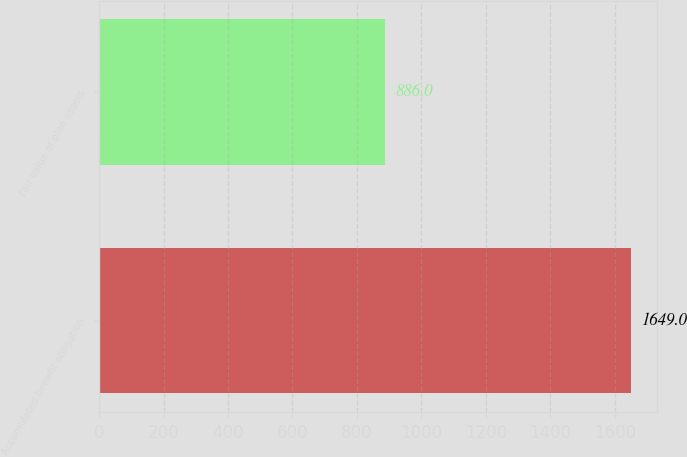Convert chart to OTSL. <chart><loc_0><loc_0><loc_500><loc_500><bar_chart><fcel>Accumulated benefit obligation<fcel>Fair value of plan assets<nl><fcel>1649<fcel>886<nl></chart> 